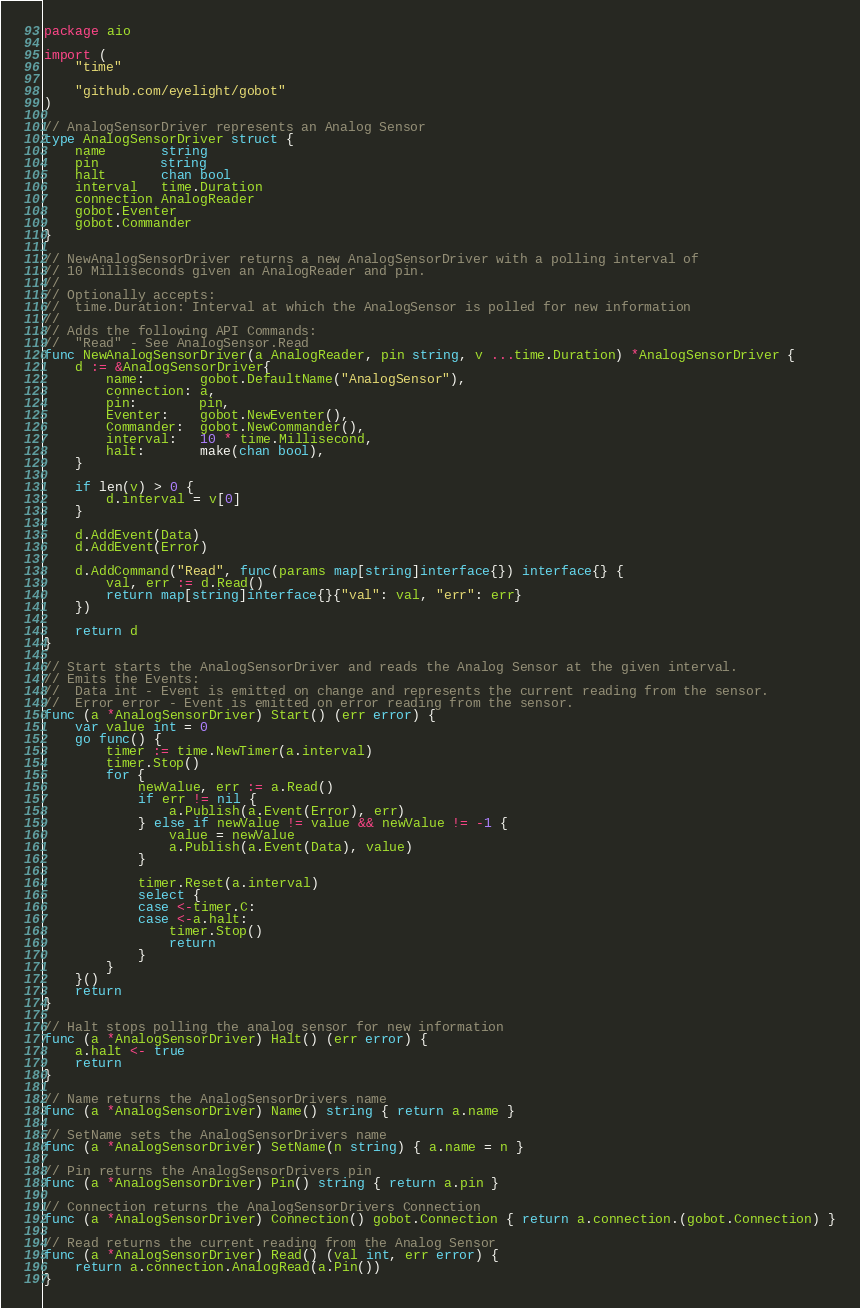<code> <loc_0><loc_0><loc_500><loc_500><_Go_>package aio

import (
	"time"

	"github.com/eyelight/gobot"
)

// AnalogSensorDriver represents an Analog Sensor
type AnalogSensorDriver struct {
	name       string
	pin        string
	halt       chan bool
	interval   time.Duration
	connection AnalogReader
	gobot.Eventer
	gobot.Commander
}

// NewAnalogSensorDriver returns a new AnalogSensorDriver with a polling interval of
// 10 Milliseconds given an AnalogReader and pin.
//
// Optionally accepts:
// 	time.Duration: Interval at which the AnalogSensor is polled for new information
//
// Adds the following API Commands:
// 	"Read" - See AnalogSensor.Read
func NewAnalogSensorDriver(a AnalogReader, pin string, v ...time.Duration) *AnalogSensorDriver {
	d := &AnalogSensorDriver{
		name:       gobot.DefaultName("AnalogSensor"),
		connection: a,
		pin:        pin,
		Eventer:    gobot.NewEventer(),
		Commander:  gobot.NewCommander(),
		interval:   10 * time.Millisecond,
		halt:       make(chan bool),
	}

	if len(v) > 0 {
		d.interval = v[0]
	}

	d.AddEvent(Data)
	d.AddEvent(Error)

	d.AddCommand("Read", func(params map[string]interface{}) interface{} {
		val, err := d.Read()
		return map[string]interface{}{"val": val, "err": err}
	})

	return d
}

// Start starts the AnalogSensorDriver and reads the Analog Sensor at the given interval.
// Emits the Events:
//	Data int - Event is emitted on change and represents the current reading from the sensor.
//	Error error - Event is emitted on error reading from the sensor.
func (a *AnalogSensorDriver) Start() (err error) {
	var value int = 0
	go func() {
		timer := time.NewTimer(a.interval)
		timer.Stop()
		for {
			newValue, err := a.Read()
			if err != nil {
				a.Publish(a.Event(Error), err)
			} else if newValue != value && newValue != -1 {
				value = newValue
				a.Publish(a.Event(Data), value)
			}

			timer.Reset(a.interval)
			select {
			case <-timer.C:
			case <-a.halt:
				timer.Stop()
				return
			}
		}
	}()
	return
}

// Halt stops polling the analog sensor for new information
func (a *AnalogSensorDriver) Halt() (err error) {
	a.halt <- true
	return
}

// Name returns the AnalogSensorDrivers name
func (a *AnalogSensorDriver) Name() string { return a.name }

// SetName sets the AnalogSensorDrivers name
func (a *AnalogSensorDriver) SetName(n string) { a.name = n }

// Pin returns the AnalogSensorDrivers pin
func (a *AnalogSensorDriver) Pin() string { return a.pin }

// Connection returns the AnalogSensorDrivers Connection
func (a *AnalogSensorDriver) Connection() gobot.Connection { return a.connection.(gobot.Connection) }

// Read returns the current reading from the Analog Sensor
func (a *AnalogSensorDriver) Read() (val int, err error) {
	return a.connection.AnalogRead(a.Pin())
}
</code> 